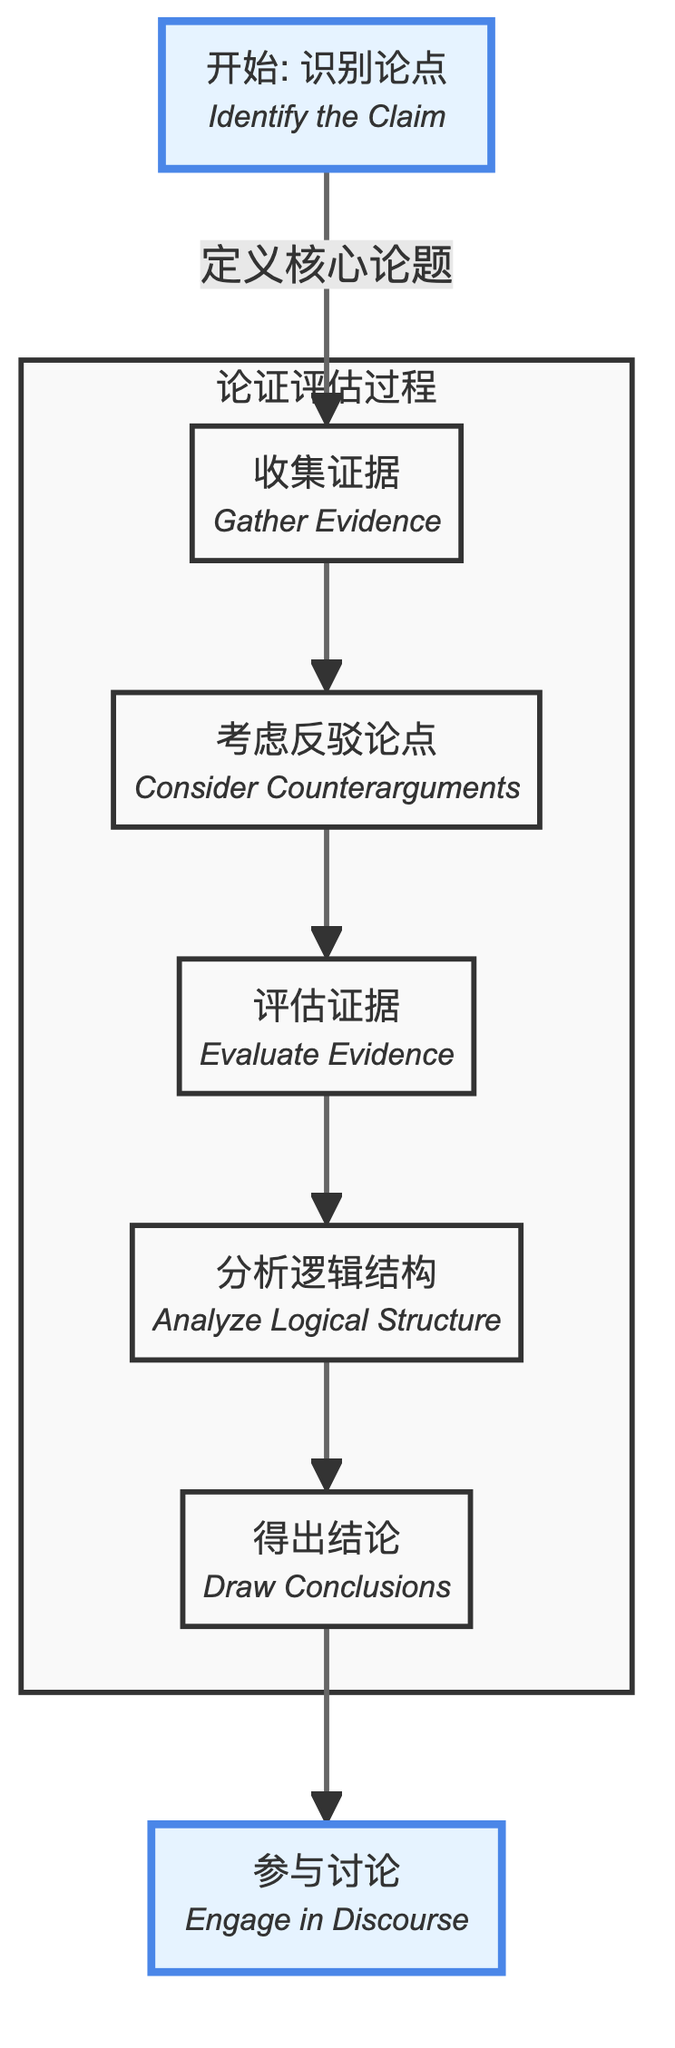What is the first step in the process? The first step in the process is represented by the node labeled "Identify the Claim," which is crucial for defining the central thesis to be evaluated.
Answer: Identify the Claim How many elements are in the flowchart? By counting each node labeled in the diagram, we find there are a total of 7 elements, which represent distinct steps in the philosophical argument evaluation process.
Answer: 7 What is the last step before engaging in discourse? The last step before engaging in discourse is "Draw Conclusions," which is the final stage of evaluating the claim based on the gathered evidence and logical analysis.
Answer: Draw Conclusions What do you do after gathering evidence? After gathering evidence, the next step is to "Consider Counterarguments," which involves identifying opposing viewpoints to the original claim.
Answer: Consider Counterarguments What are the steps included in the argument evaluation process? The steps included in the argument evaluation process, as outlined in the subgraph, are: Gather Evidence, Consider Counterarguments, Evaluate Evidence, Analyze Logical Structure, and Draw Conclusions.
Answer: Gather Evidence, Consider Counterarguments, Evaluate Evidence, Analyze Logical Structure, Draw Conclusions What is the relationship between "Evaluate Evidence" and "Consider Counterarguments"? The relationship between "Evaluate Evidence" and "Consider Counterarguments" is sequential; after considering counterarguments, the process leads to evaluating the credibility and relevance of the gathered evidence.
Answer: Sequential How many steps are taken to reach a conclusion? To reach a conclusion, a total of 5 steps must be taken: Gather Evidence, Consider Counterarguments, Evaluate Evidence, Analyze Logical Structure, and finally Draw Conclusions.
Answer: 5 steps What is the purpose of drawing conclusions? The purpose of drawing conclusions is to determine the validity of the claim based on the entire evaluation process conducted prior.
Answer: Determine the validity of the claim 